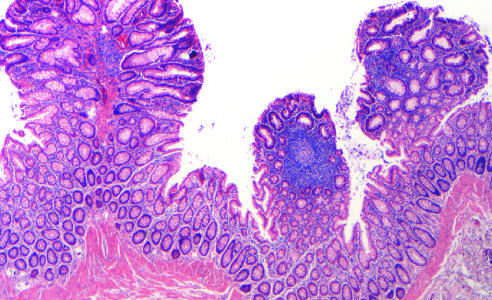where are three tubular adenomas present?
Answer the question using a single word or phrase. In a single microscopic field 